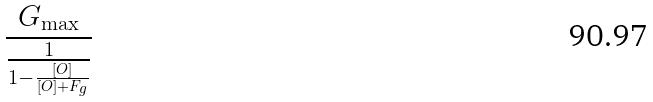<formula> <loc_0><loc_0><loc_500><loc_500>\frac { G _ { \max } } { \frac { 1 } { 1 - \frac { [ O ] } { [ O ] + F _ { g } } } }</formula> 